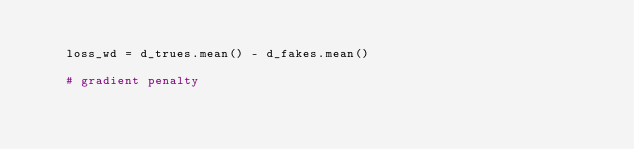<code> <loc_0><loc_0><loc_500><loc_500><_Python_>
    loss_wd = d_trues.mean() - d_fakes.mean()

    # gradient penalty</code> 